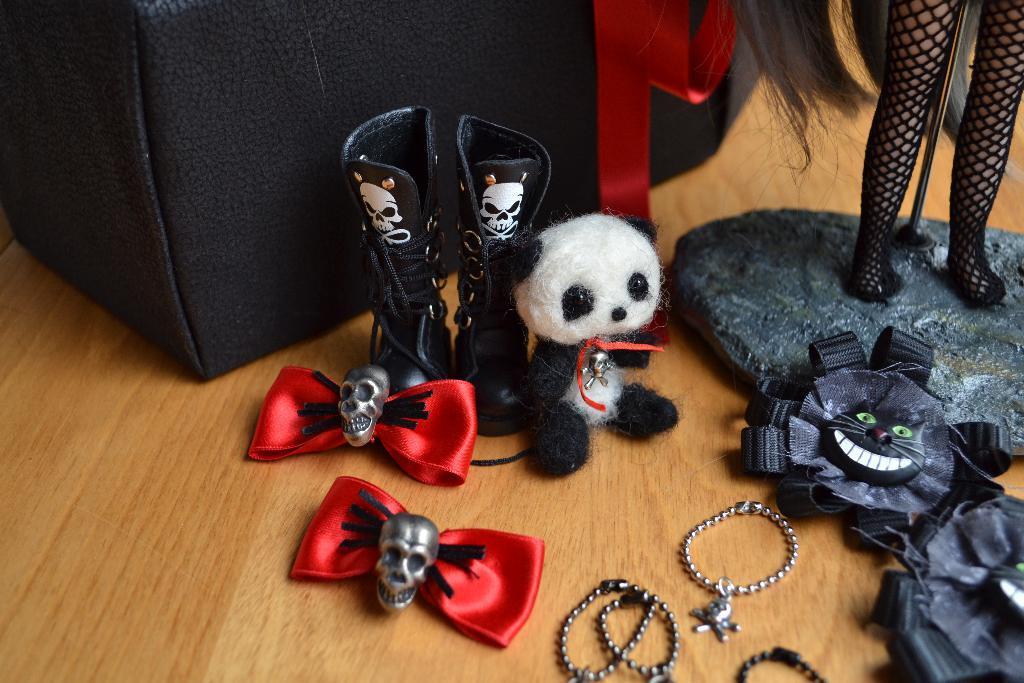Can you describe this image briefly? In this image I can see toys kept on the floor and I can see some clothes and chains visible on the floor and I can see black color box visible on floor. 